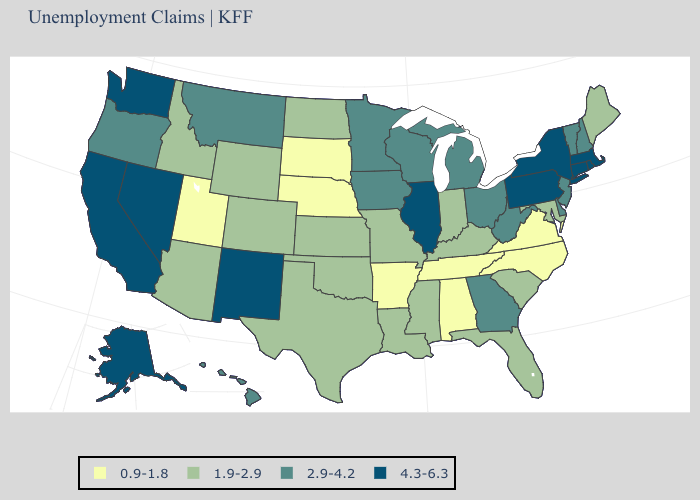Name the states that have a value in the range 0.9-1.8?
Give a very brief answer. Alabama, Arkansas, Nebraska, North Carolina, South Dakota, Tennessee, Utah, Virginia. Name the states that have a value in the range 1.9-2.9?
Be succinct. Arizona, Colorado, Florida, Idaho, Indiana, Kansas, Kentucky, Louisiana, Maine, Maryland, Mississippi, Missouri, North Dakota, Oklahoma, South Carolina, Texas, Wyoming. What is the value of Kentucky?
Answer briefly. 1.9-2.9. Which states hav the highest value in the West?
Concise answer only. Alaska, California, Nevada, New Mexico, Washington. Which states have the lowest value in the USA?
Short answer required. Alabama, Arkansas, Nebraska, North Carolina, South Dakota, Tennessee, Utah, Virginia. What is the value of Louisiana?
Answer briefly. 1.9-2.9. Name the states that have a value in the range 4.3-6.3?
Quick response, please. Alaska, California, Connecticut, Illinois, Massachusetts, Nevada, New Mexico, New York, Pennsylvania, Rhode Island, Washington. What is the lowest value in the MidWest?
Short answer required. 0.9-1.8. Does the map have missing data?
Be succinct. No. Name the states that have a value in the range 2.9-4.2?
Short answer required. Delaware, Georgia, Hawaii, Iowa, Michigan, Minnesota, Montana, New Hampshire, New Jersey, Ohio, Oregon, Vermont, West Virginia, Wisconsin. What is the value of Kansas?
Write a very short answer. 1.9-2.9. What is the value of Nebraska?
Answer briefly. 0.9-1.8. Name the states that have a value in the range 2.9-4.2?
Short answer required. Delaware, Georgia, Hawaii, Iowa, Michigan, Minnesota, Montana, New Hampshire, New Jersey, Ohio, Oregon, Vermont, West Virginia, Wisconsin. Which states hav the highest value in the South?
Keep it brief. Delaware, Georgia, West Virginia. Does the map have missing data?
Write a very short answer. No. 